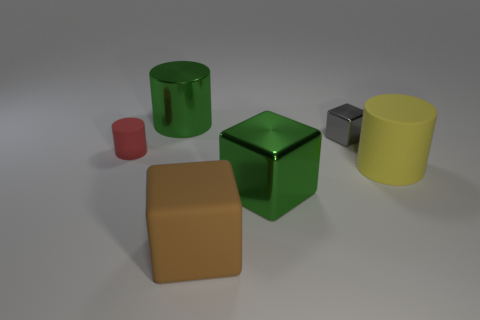How many other objects are there of the same shape as the yellow matte object?
Make the answer very short. 2. What number of objects are green metal objects in front of the metal cylinder or matte objects that are right of the green metal cylinder?
Your answer should be very brief. 3. There is a object that is both behind the red matte thing and on the right side of the green metallic cube; what is its size?
Keep it short and to the point. Small. Do the green shiny object in front of the red matte cylinder and the red object have the same shape?
Offer a very short reply. No. How big is the thing on the right side of the small object right of the big green shiny object behind the yellow thing?
Make the answer very short. Large. There is a object that is the same color as the large metallic cylinder; what is its size?
Your response must be concise. Large. What number of objects are either matte blocks or tiny cubes?
Your response must be concise. 2. What shape is the object that is behind the red thing and right of the large green block?
Ensure brevity in your answer.  Cube. Do the tiny matte object and the big green shiny object that is behind the tiny gray cube have the same shape?
Give a very brief answer. Yes. There is a brown object; are there any big green metal cylinders in front of it?
Your answer should be very brief. No. 